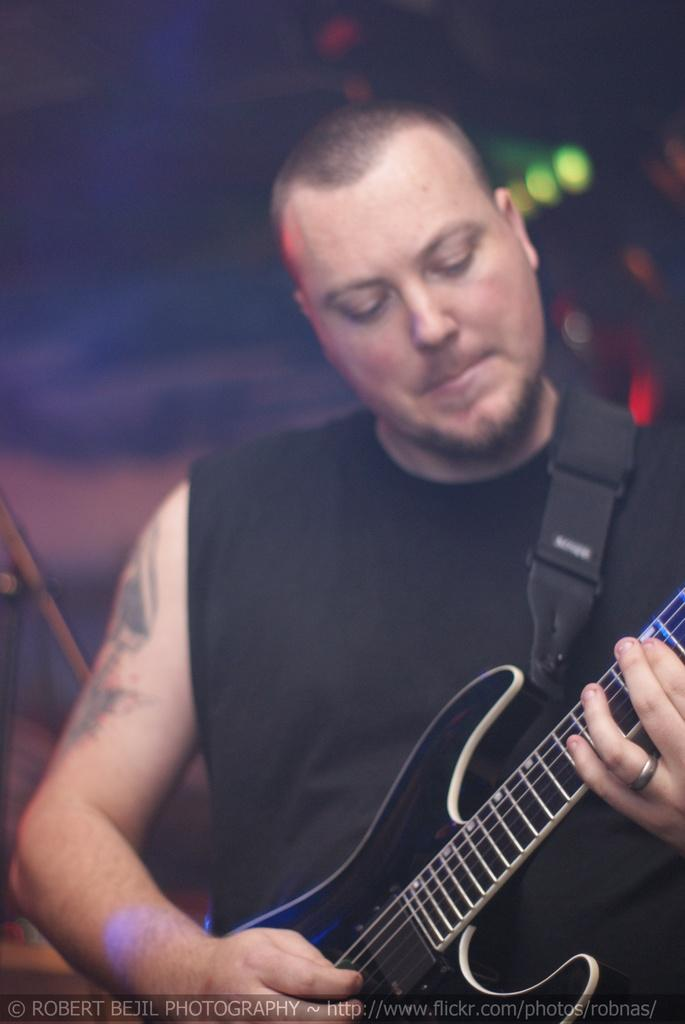Who is the main subject in the image? There is a man in the image. What is the man wearing? The man is wearing a black t-shirt. What is the man doing in the image? The man is playing a guitar. Can you describe any accessories the man is wearing? The man has a ring on his finger. How would you describe the background of the image? The background of the image is blurry. What type of rail can be seen in the image? There is no rail present in the image. What appliance is the man using to play the guitar in the image? The man is playing the guitar directly, without the use of any appliances. 